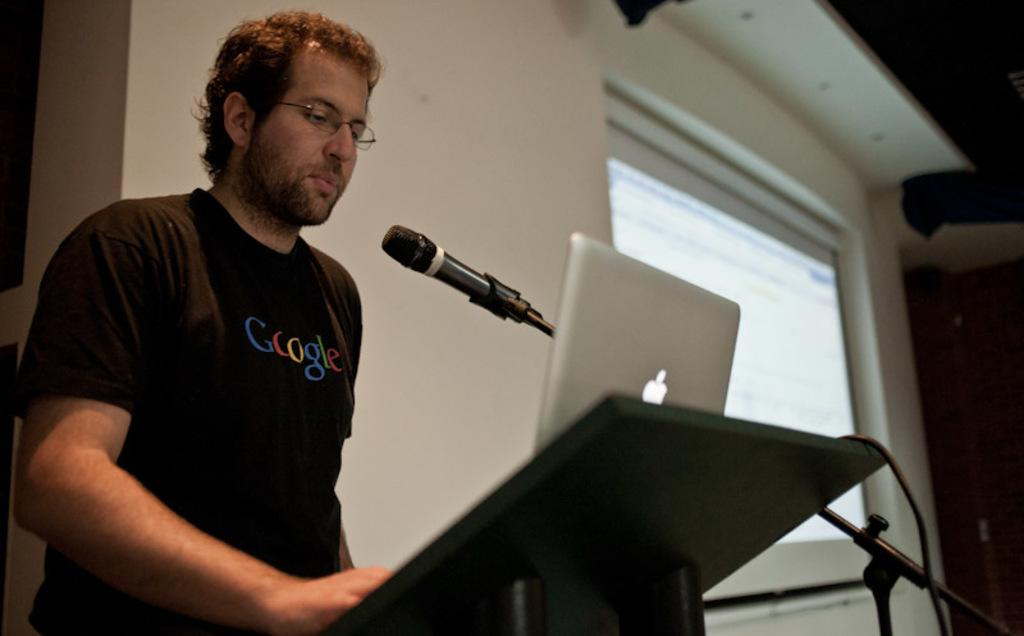What is the person in the image doing? The person is standing on the stage. What object is near the person on the stage? The person is near a podium. What electronic device is on the podium? There is a laptop on the podium. What is used for amplifying the person's voice in the image? There is a microphone on a stand on the podium. What can be seen in the background of the image? There is a screen in the image. How many letters are being carried by the goose in the image? There is no goose present in the image, and therefore no letters being carried. 